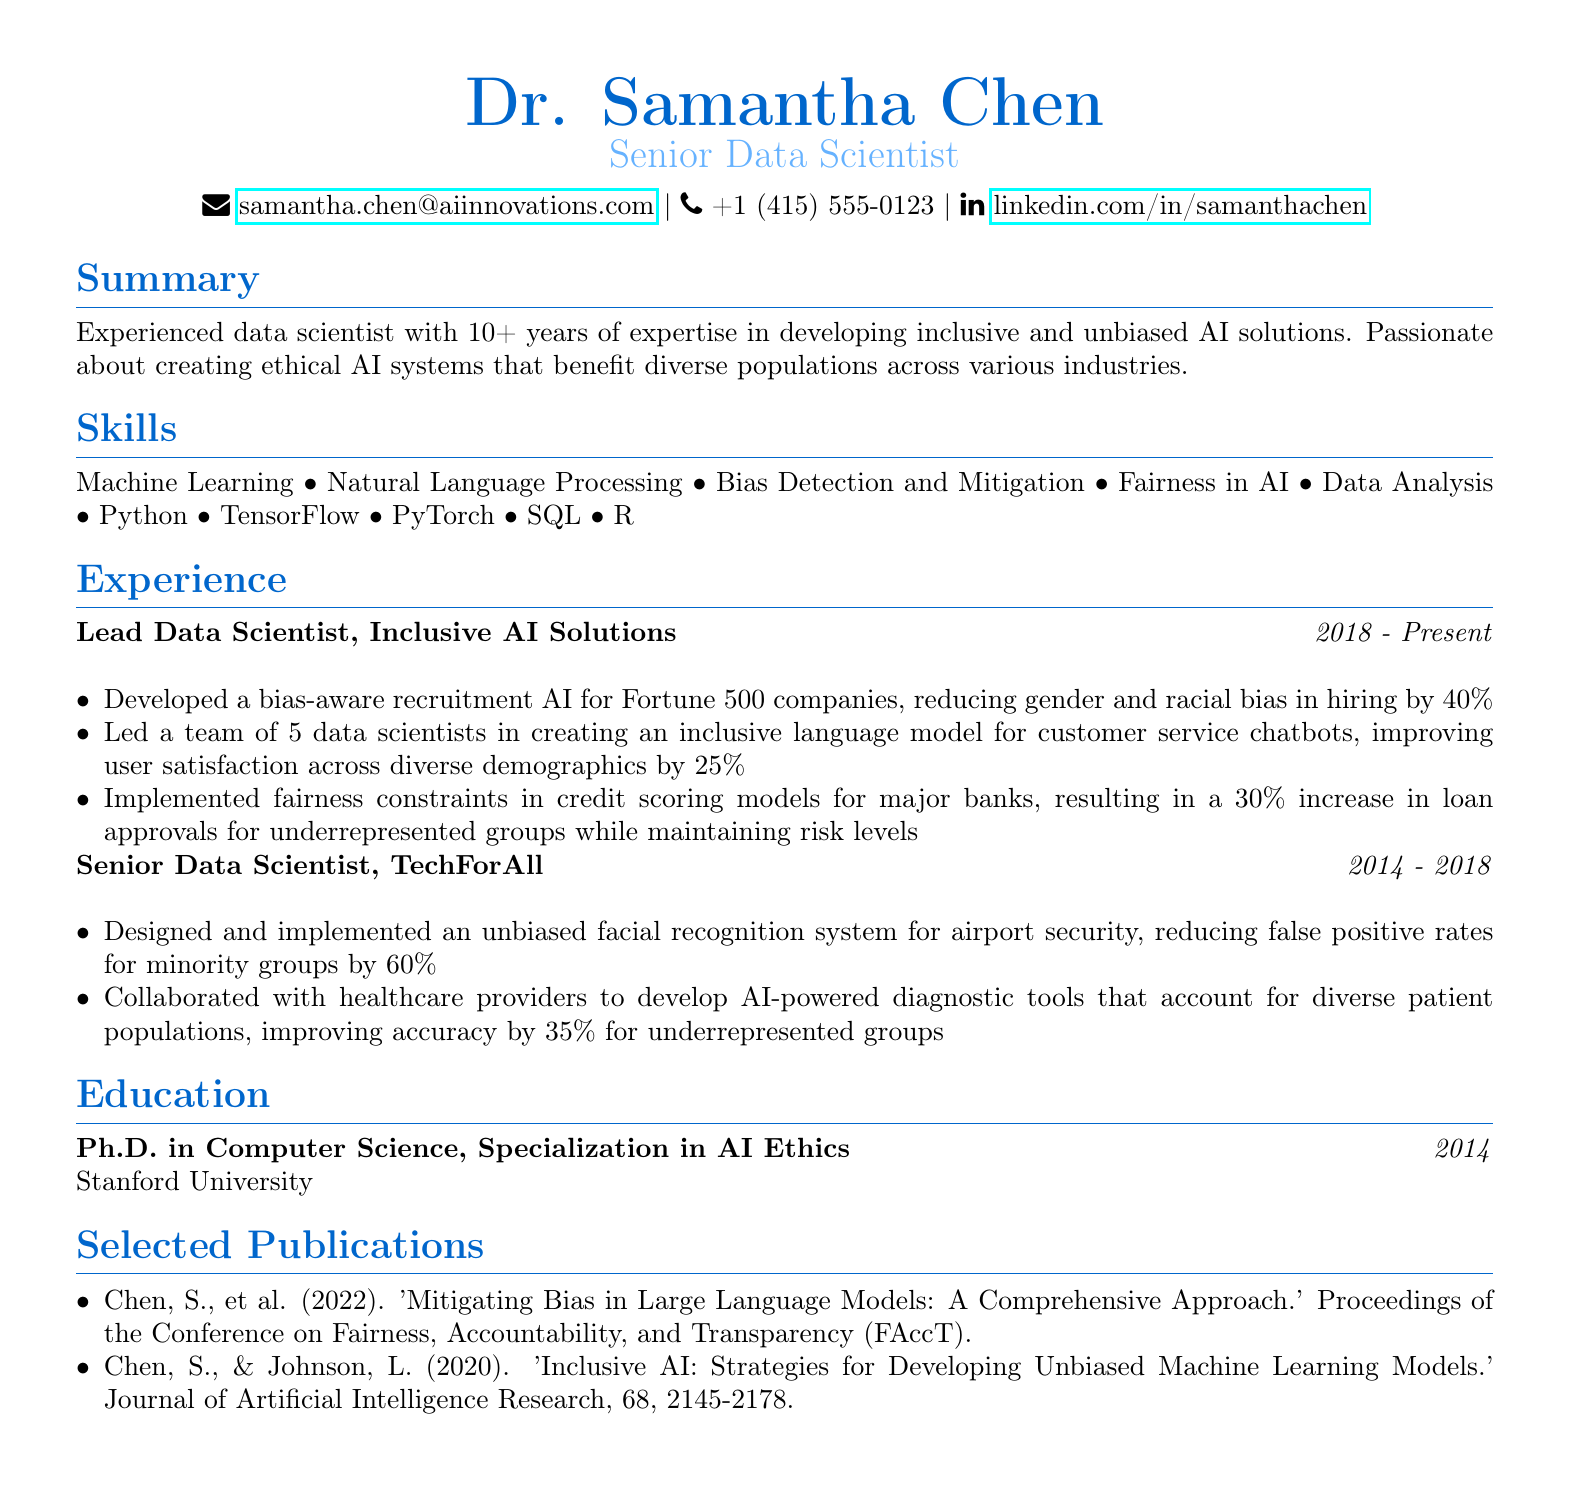What is the name of the individual? The individual's name is prominently displayed at the top of the resume.
Answer: Dr. Samantha Chen What is the title listed on the resume? The title is mentioned right below the name, indicating the professional role.
Answer: Senior Data Scientist In which year did Dr. Chen complete her Ph.D.? The year of completion is stated in the education section of the resume.
Answer: 2014 How many years of experience does Dr. Chen have? The total years of experience is summarized in the summary section.
Answer: 10+ What company did Dr. Chen work for as a Senior Data Scientist? The company name is specified in the experience section under her prior position.
Answer: TechForAll What percentage did the biased recruitment AI reduce bias by? This figure is provided among the achievements of Dr. Chen in her current role.
Answer: 40% Which major industry did Dr. Chen’s unbiased facial recognition system impact? The specific context is mentioned in the achievements section.
Answer: Airport security How many publications are listed in the document? The number of publications can be determined by counting the items in the selected publications section.
Answer: 2 What was the focus of Dr. Chen's Ph.D. specialization? This detail is included in the education section indicating the emphasis of her studies.
Answer: AI Ethics 